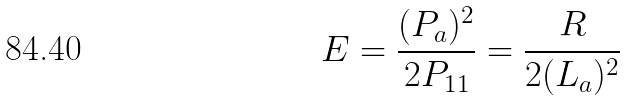Convert formula to latex. <formula><loc_0><loc_0><loc_500><loc_500>E = \frac { ( P _ { a } ) ^ { 2 } } { 2 P _ { 1 1 } } = \frac { R } { 2 ( L _ { a } ) ^ { 2 } }</formula> 